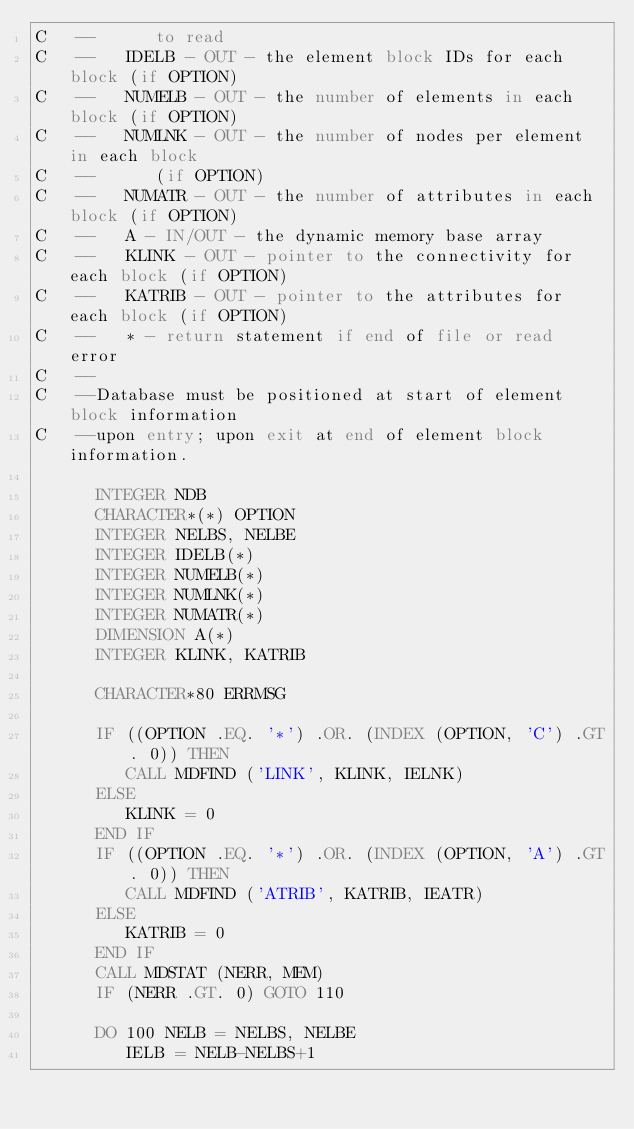<code> <loc_0><loc_0><loc_500><loc_500><_FORTRAN_>C   --      to read
C   --   IDELB - OUT - the element block IDs for each block (if OPTION)
C   --   NUMELB - OUT - the number of elements in each block (if OPTION)
C   --   NUMLNK - OUT - the number of nodes per element in each block
C   --      (if OPTION)
C   --   NUMATR - OUT - the number of attributes in each block (if OPTION)
C   --   A - IN/OUT - the dynamic memory base array
C   --   KLINK - OUT - pointer to the connectivity for each block (if OPTION)
C   --   KATRIB - OUT - pointer to the attributes for each block (if OPTION)
C   --   * - return statement if end of file or read error
C   --
C   --Database must be positioned at start of element block information
C   --upon entry; upon exit at end of element block information.

      INTEGER NDB
      CHARACTER*(*) OPTION
      INTEGER NELBS, NELBE
      INTEGER IDELB(*)
      INTEGER NUMELB(*)
      INTEGER NUMLNK(*)
      INTEGER NUMATR(*)
      DIMENSION A(*)
      INTEGER KLINK, KATRIB

      CHARACTER*80 ERRMSG

      IF ((OPTION .EQ. '*') .OR. (INDEX (OPTION, 'C') .GT. 0)) THEN
         CALL MDFIND ('LINK', KLINK, IELNK)
      ELSE
         KLINK = 0
      END IF
      IF ((OPTION .EQ. '*') .OR. (INDEX (OPTION, 'A') .GT. 0)) THEN
         CALL MDFIND ('ATRIB', KATRIB, IEATR)
      ELSE
         KATRIB = 0
      END IF
      CALL MDSTAT (NERR, MEM)
      IF (NERR .GT. 0) GOTO 110

      DO 100 NELB = NELBS, NELBE
         IELB = NELB-NELBS+1
</code> 